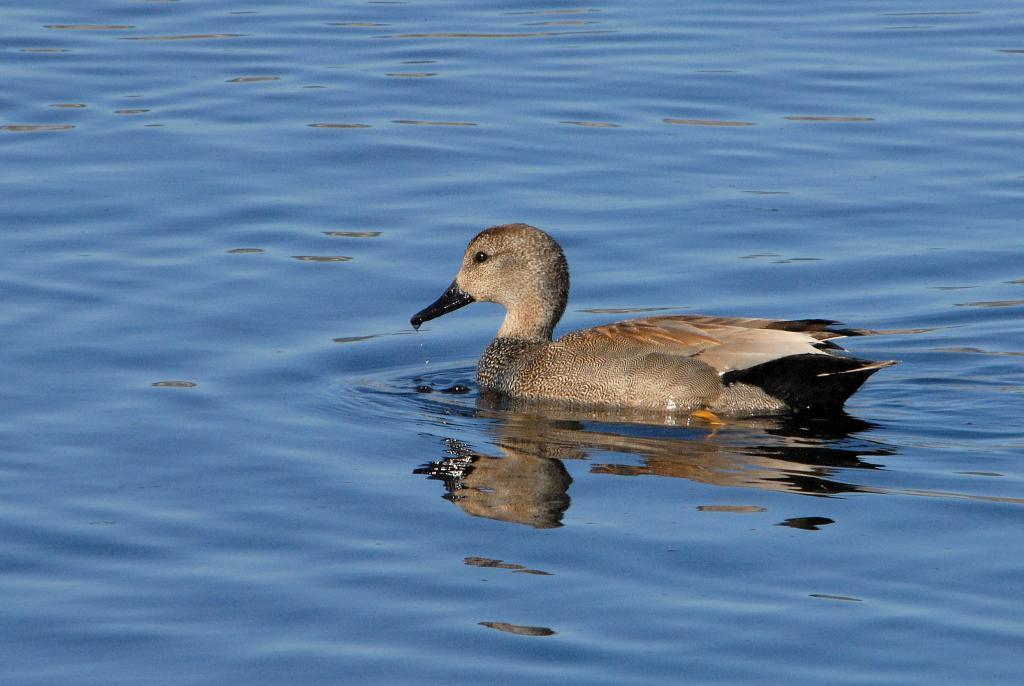How would you summarize this image in a sentence or two? In this image there is a duck, on a water surface. 